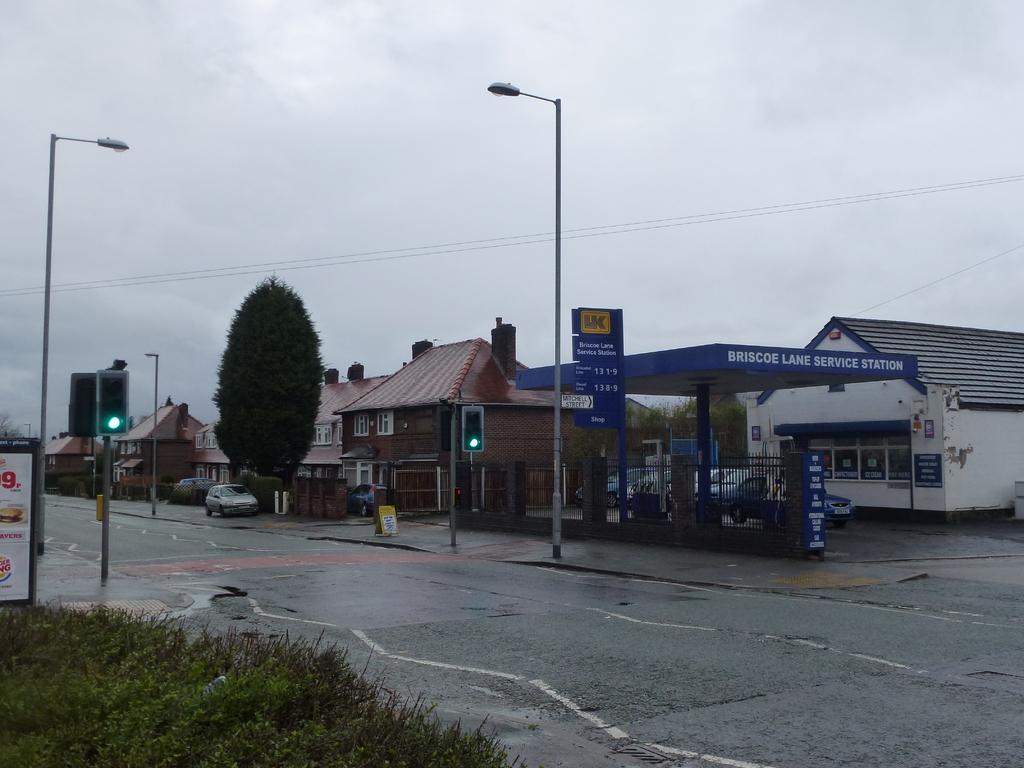Can you describe this image briefly? In this picture we can see the road, plants, poles, traffic signals, vehicles, trees, poster, houses with windows, some objects and in the background we can see the sky. 